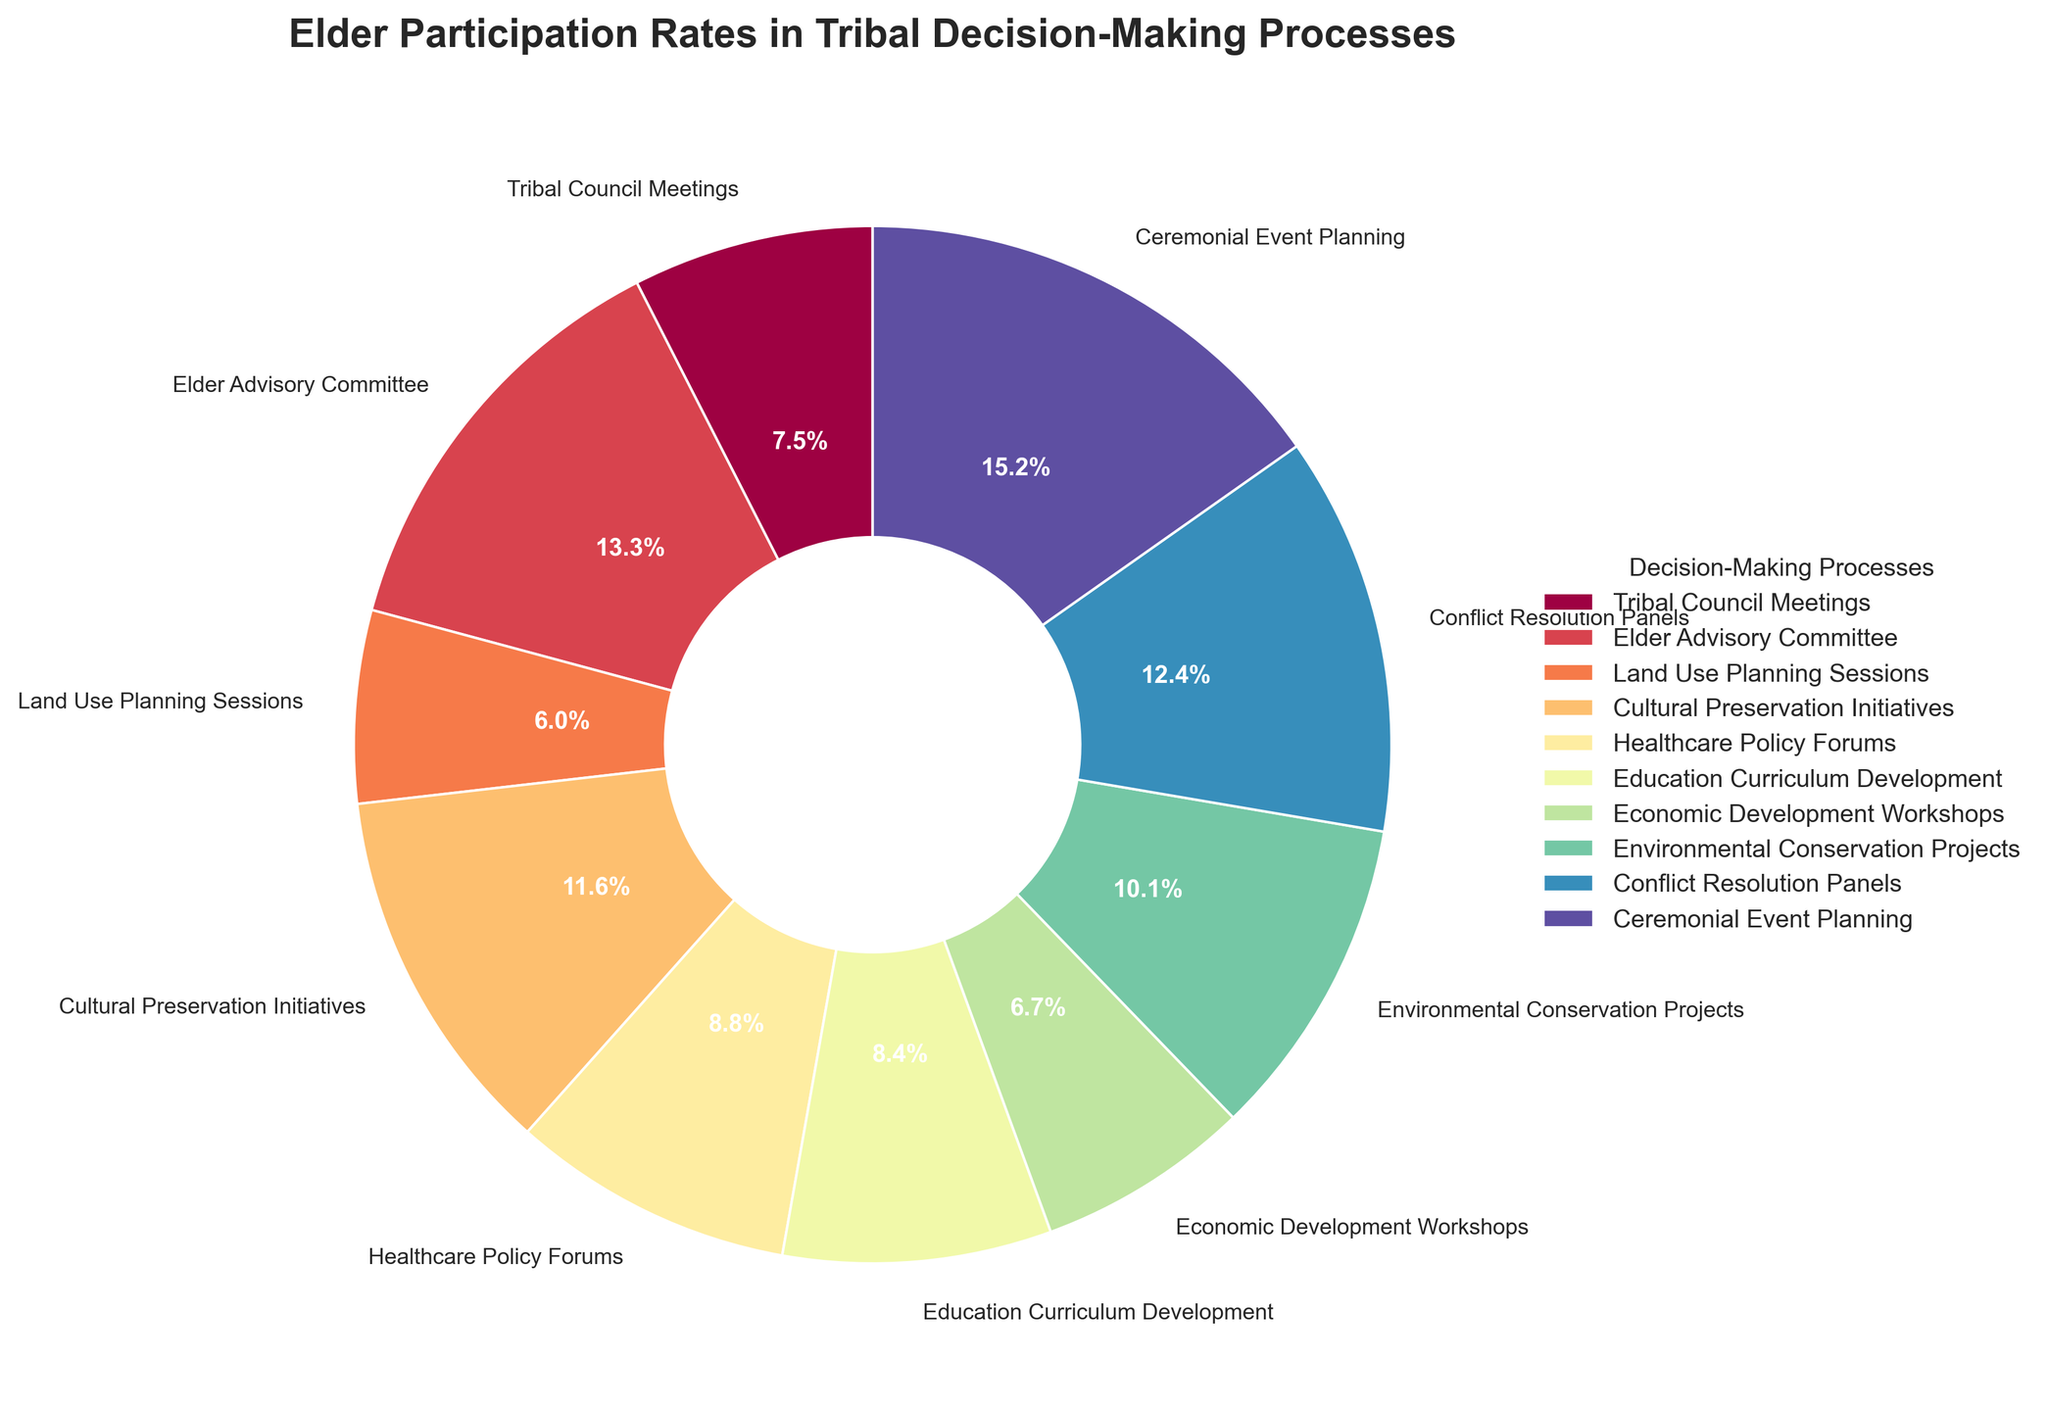What's the highest Elder participation rate in any decision-making process? The highest participation rate is found by looking at all the percentages and identifying the maximum one. The highest percentage is 71% for Ceremonial Event Planning.
Answer: 71% Which decision-making process has the lowest Elder participation rate? To determine the lowest participation rate, compare all the percentages and identify the minimum one. The lowest percentage is 28% for Land Use Planning Sessions.
Answer: Land Use Planning Sessions What is the total Elder participation rate for Healthcare Policy Forums and Education Curriculum Development? Add the participation rates for Healthcare Policy Forums (41%) and Education Curriculum Development (39%). 41% + 39% = 80%.
Answer: 80% Is the participation rate for the Elder Advisory Committee higher than for Economic Development Workshops? Compare the rates: Elder Advisory Committee (62%) vs. Economic Development Workshops (31%). Since 62% is greater than 31%, the answer is yes.
Answer: Yes Are there more processes with Elder participation rates below 50% or above 50%? Count the number of processes below 50% (5: Tribal Council Meetings, Land Use Planning Sessions, Healthcare Policy Forums, Education Curriculum Development, Economic Development Workshops) and above 50% (5: Elder Advisory Committee, Cultural Preservation Initiatives, Environmental Conservation Projects, Conflict Resolution Panels, Ceremonial Event Planning). Both counts equal five.
Answer: Equal What's the average Elder participation rate across all decision-making processes? Sum all the participation rates and divide by the number of processes. Total is (35 + 62 + 28 + 54 + 41 + 39 + 31 + 47 + 58 + 71) = 466. The average is 466 / 10 = 46.6%.
Answer: 46.6% How much higher is the participation rate in Ceremonial Event Planning than in Tribal Council Meetings? Subtract the rate of Tribal Council Meetings (35%) from Ceremonial Event Planning (71%). 71% - 35% = 36%.
Answer: 36% Which decision-making process is represented by the wedge after the one for the Healthcare Policy Forums when going clockwise around the pie chart? Identify the process order and go one step clockwise from Healthcare Policy Forums (41%). The next wedge represents Education Curriculum Development (39%).
Answer: Education Curriculum Development Which decision-making process has a visual slice that's predominantly a bright color? The decision-making process labeled "Ceremonial Event Planning" appears with the most visually striking color; usually bright colors indicate important segments.
Answer: Ceremonial Event Planning 